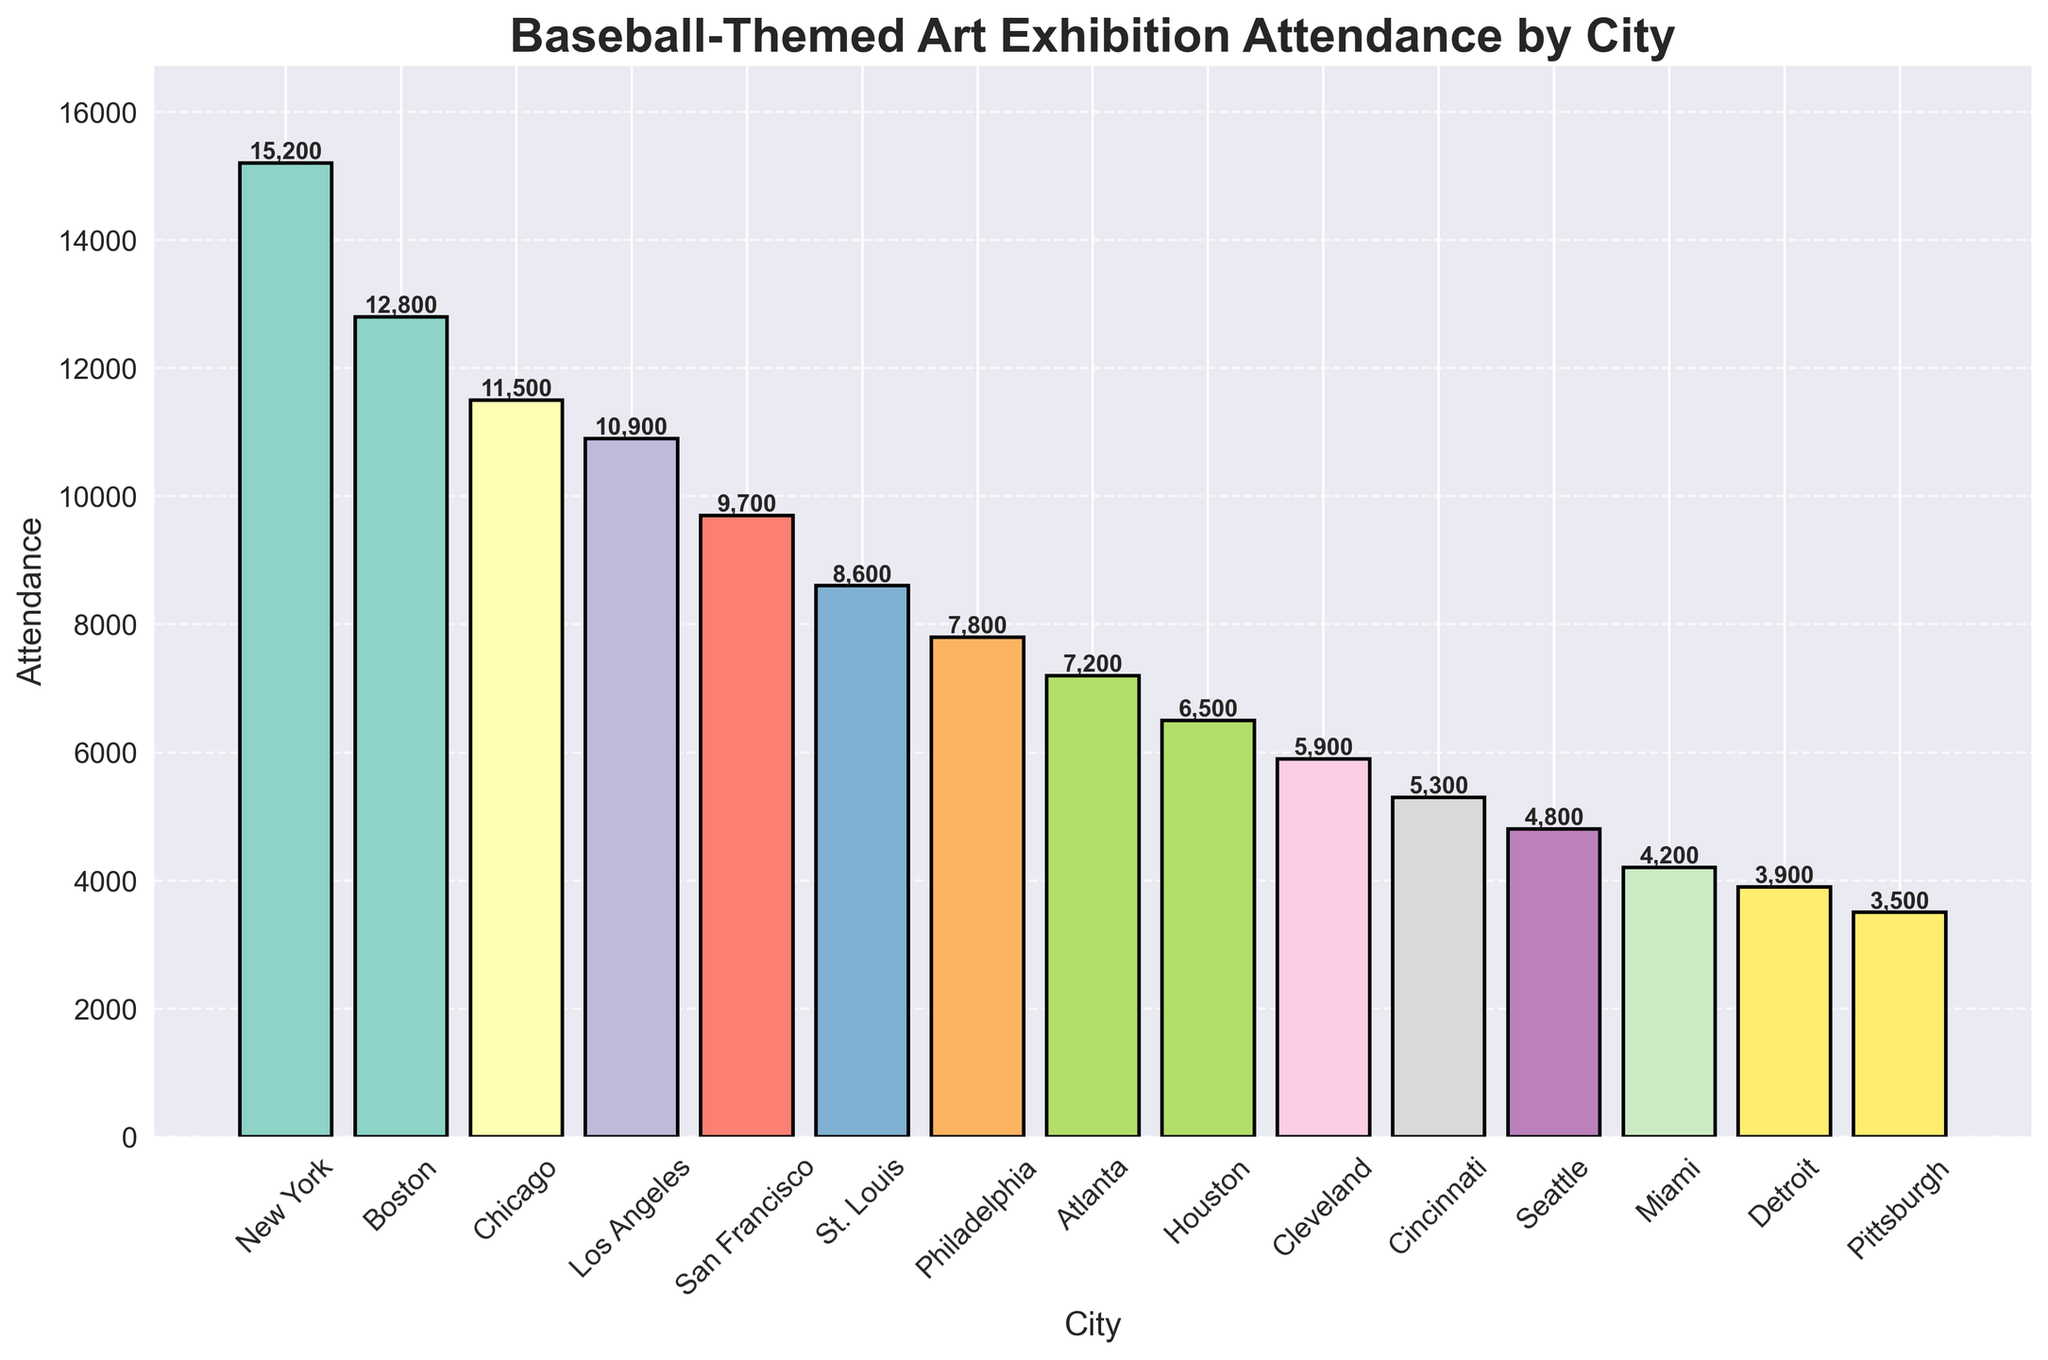What's the city with the highest attendance? The bar for New York is the tallest, representing the highest attendance figure.
Answer: New York Which city has the lowest attendance figure? The bar for Pittsburgh is the shortest, indicating the lowest attendance figure.
Answer: Pittsburgh What's the difference in attendance between New York and Pittsburgh? New York has an attendance of 15,200 and Pittsburgh has 3,500. Subtract Pittsburgh's attendance from New York's: 15,200 - 3,500.
Answer: 11,700 How many cities have attendance figures over 10,000? Create a list of cities with bars higher than the 10,000 mark: New York, Boston, Chicago, Los Angeles. This list contains 4 cities.
Answer: 4 What’s the average attendance across all cities? Sum the attendance figures for all cities: 15200 + 12800 + 11500 + 10900 + 9700 + 8600 + 7800 + 7200 + 6500 + 5900 + 5300 + 4800 + 4200 + 3900 + 3500 = 129,000. Divide by the number of cities (15): 129,000 / 15.
Answer: 8,600 Which cities have attendance figures greater than 12,000 but less than 15,000? Cities with attendance within the specified range: Boston (12,800).
Answer: Boston What's the combined attendance for Los Angeles and San Francisco? Los Angeles has 10,900 and San Francisco has 9,700. Adding these together: 10,900 + 9,700.
Answer: 20,600 Is the attendance in Boston greater than twice the attendance in Pittsburgh? Boston's attendance is 12,800. Twice Pittsburgh's attendance is: 2 * 3,500 = 7,000. Compare the two values: 12,800 > 7,000.
Answer: Yes Which city has the second highest attendance? The bar for Boston is the second tallest, indicating it has the second highest attendance.
Answer: Boston How much higher is Chicago's attendance compared to Seattle's? Chicago has 11,500 and Seattle has 4,800. Subtract Seattle's attendance from Chicago's: 11,500 - 4,800.
Answer: 6,700 